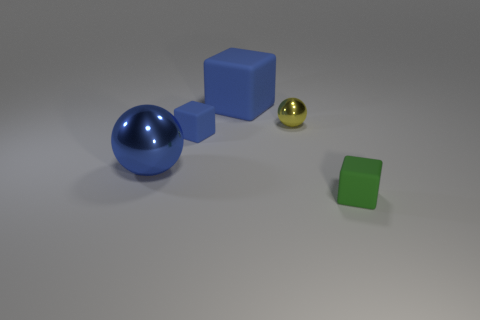Can you describe the setting where these objects are placed? The objects are positioned on a flat surface that has a slight gradient from light to dark, giving the impression of a studio setting. It appears to be a controlled environment suitable for displaying or photographing these objects clearly. 